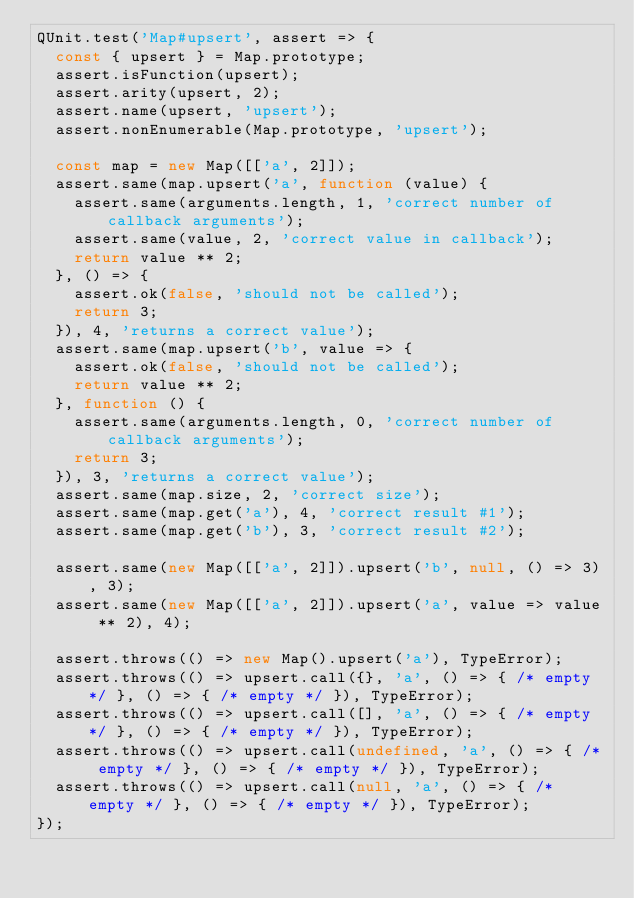<code> <loc_0><loc_0><loc_500><loc_500><_JavaScript_>QUnit.test('Map#upsert', assert => {
  const { upsert } = Map.prototype;
  assert.isFunction(upsert);
  assert.arity(upsert, 2);
  assert.name(upsert, 'upsert');
  assert.nonEnumerable(Map.prototype, 'upsert');

  const map = new Map([['a', 2]]);
  assert.same(map.upsert('a', function (value) {
    assert.same(arguments.length, 1, 'correct number of callback arguments');
    assert.same(value, 2, 'correct value in callback');
    return value ** 2;
  }, () => {
    assert.ok(false, 'should not be called');
    return 3;
  }), 4, 'returns a correct value');
  assert.same(map.upsert('b', value => {
    assert.ok(false, 'should not be called');
    return value ** 2;
  }, function () {
    assert.same(arguments.length, 0, 'correct number of callback arguments');
    return 3;
  }), 3, 'returns a correct value');
  assert.same(map.size, 2, 'correct size');
  assert.same(map.get('a'), 4, 'correct result #1');
  assert.same(map.get('b'), 3, 'correct result #2');

  assert.same(new Map([['a', 2]]).upsert('b', null, () => 3), 3);
  assert.same(new Map([['a', 2]]).upsert('a', value => value ** 2), 4);

  assert.throws(() => new Map().upsert('a'), TypeError);
  assert.throws(() => upsert.call({}, 'a', () => { /* empty */ }, () => { /* empty */ }), TypeError);
  assert.throws(() => upsert.call([], 'a', () => { /* empty */ }, () => { /* empty */ }), TypeError);
  assert.throws(() => upsert.call(undefined, 'a', () => { /* empty */ }, () => { /* empty */ }), TypeError);
  assert.throws(() => upsert.call(null, 'a', () => { /* empty */ }, () => { /* empty */ }), TypeError);
});
</code> 